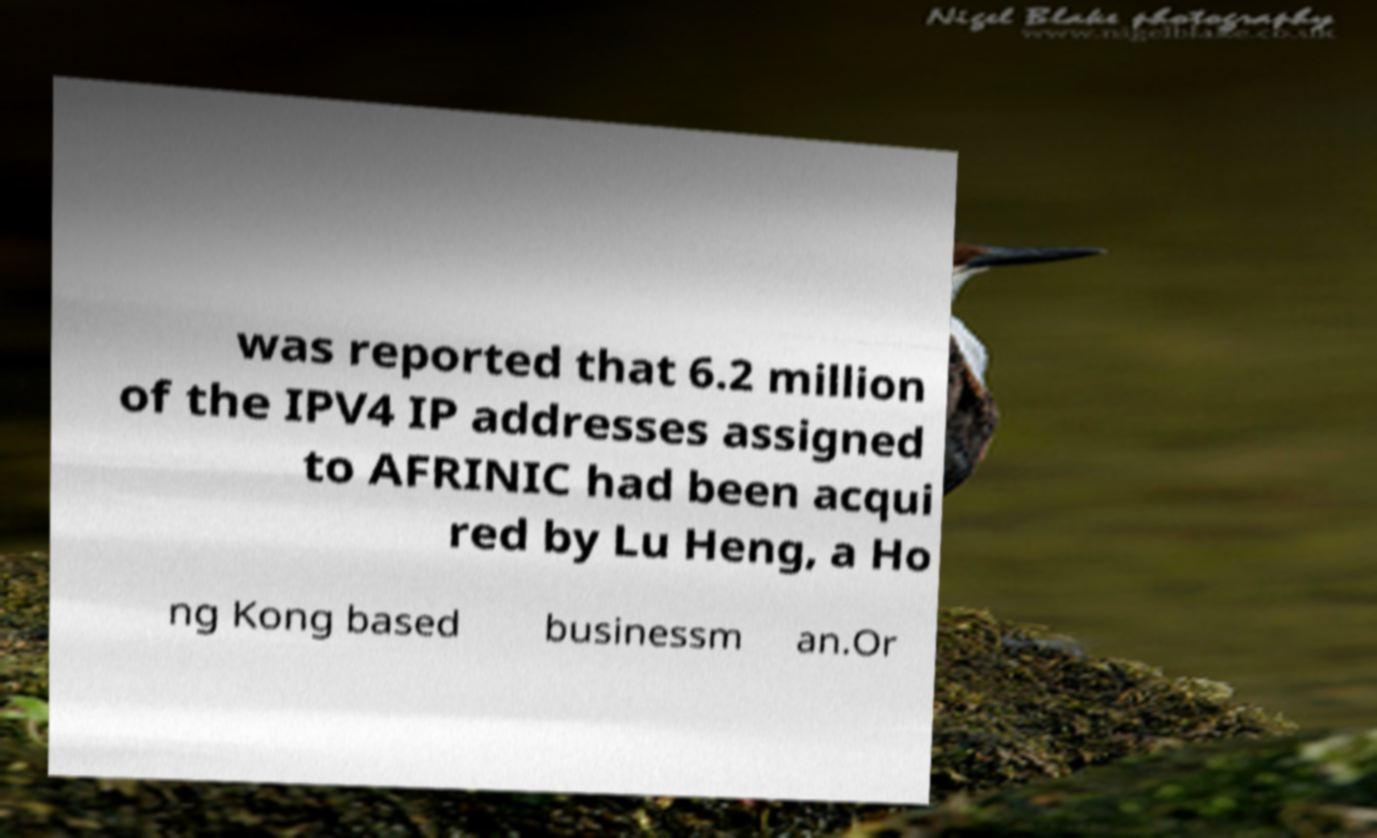Please read and relay the text visible in this image. What does it say? was reported that 6.2 million of the IPV4 IP addresses assigned to AFRINIC had been acqui red by Lu Heng, a Ho ng Kong based businessm an.Or 